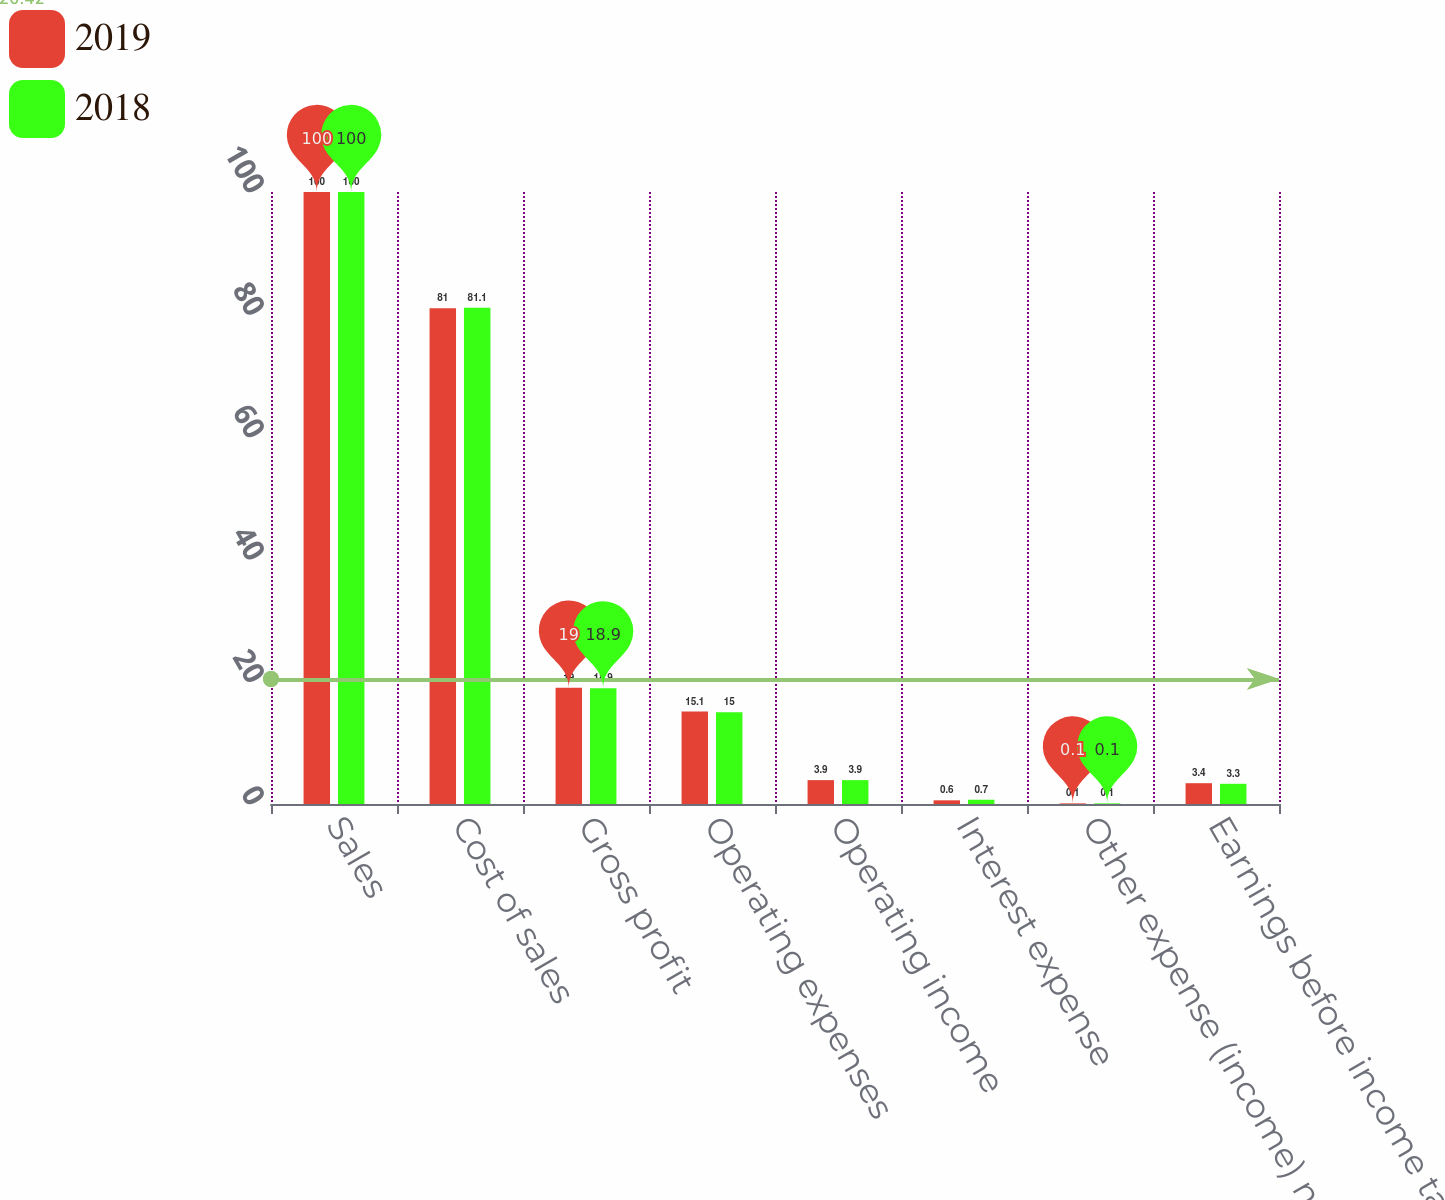Convert chart to OTSL. <chart><loc_0><loc_0><loc_500><loc_500><stacked_bar_chart><ecel><fcel>Sales<fcel>Cost of sales<fcel>Gross profit<fcel>Operating expenses<fcel>Operating income<fcel>Interest expense<fcel>Other expense (income) net<fcel>Earnings before income taxes<nl><fcel>2019<fcel>100<fcel>81<fcel>19<fcel>15.1<fcel>3.9<fcel>0.6<fcel>0.1<fcel>3.4<nl><fcel>2018<fcel>100<fcel>81.1<fcel>18.9<fcel>15<fcel>3.9<fcel>0.7<fcel>0.1<fcel>3.3<nl></chart> 